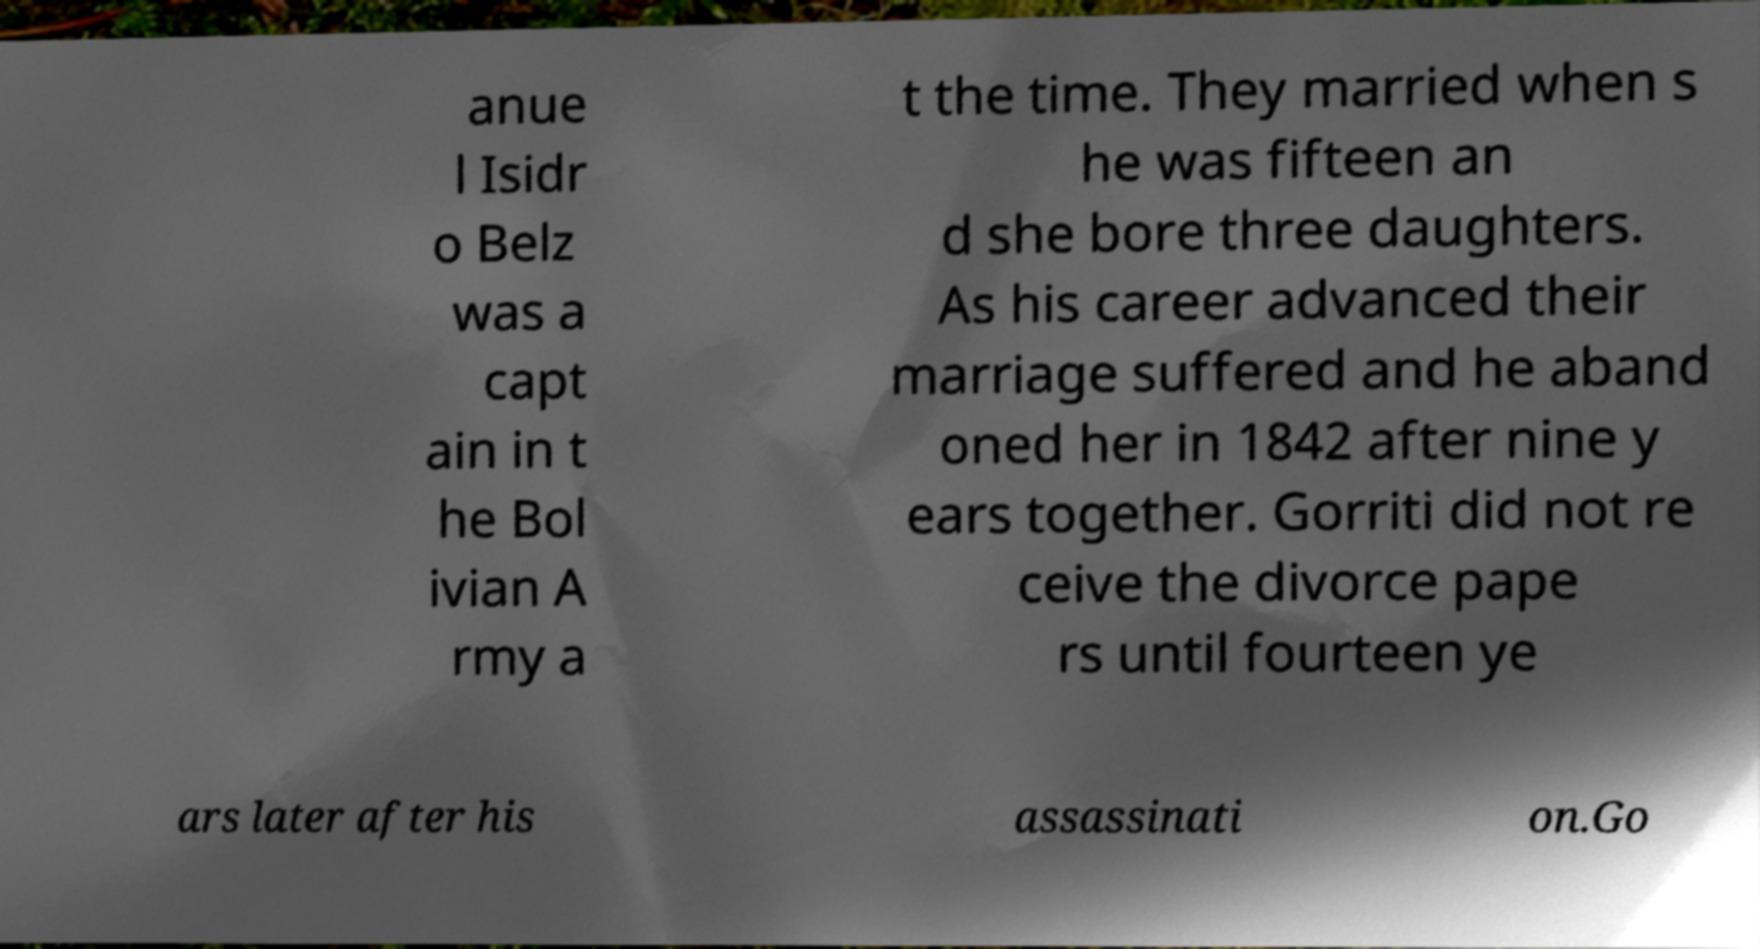Could you extract and type out the text from this image? anue l Isidr o Belz was a capt ain in t he Bol ivian A rmy a t the time. They married when s he was fifteen an d she bore three daughters. As his career advanced their marriage suffered and he aband oned her in 1842 after nine y ears together. Gorriti did not re ceive the divorce pape rs until fourteen ye ars later after his assassinati on.Go 